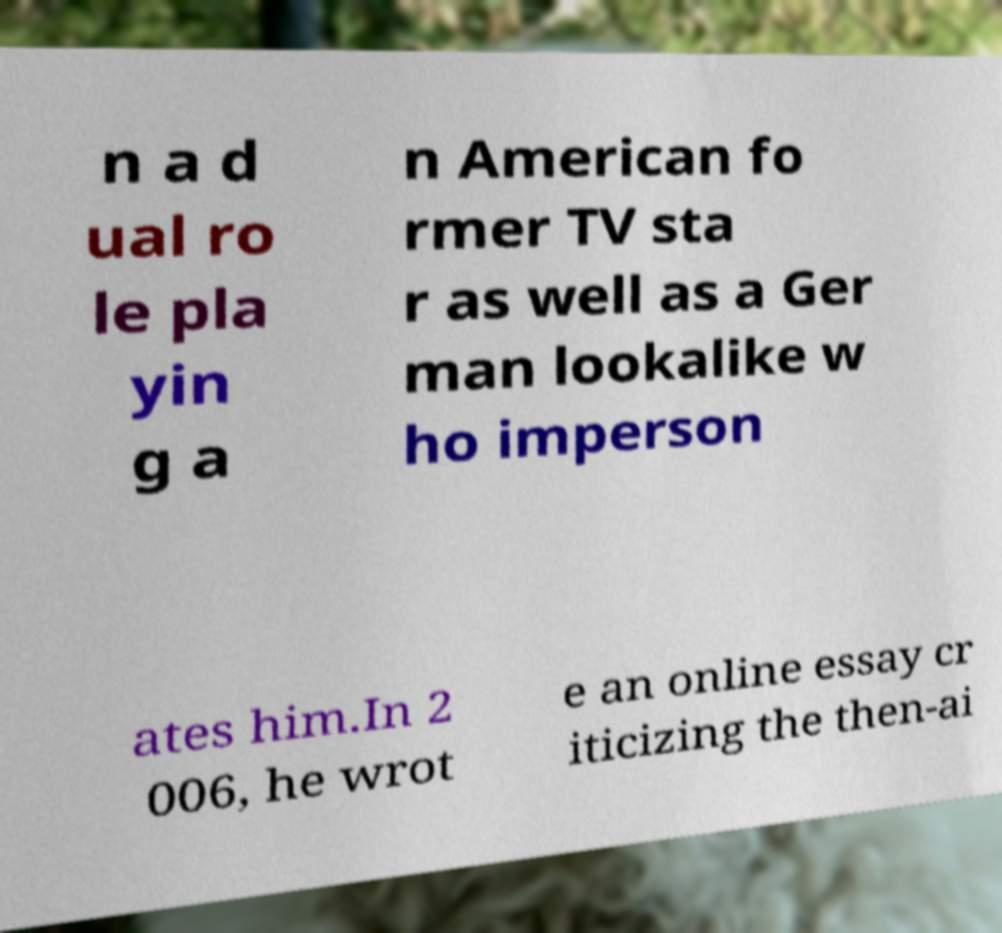Please identify and transcribe the text found in this image. n a d ual ro le pla yin g a n American fo rmer TV sta r as well as a Ger man lookalike w ho imperson ates him.In 2 006, he wrot e an online essay cr iticizing the then-ai 